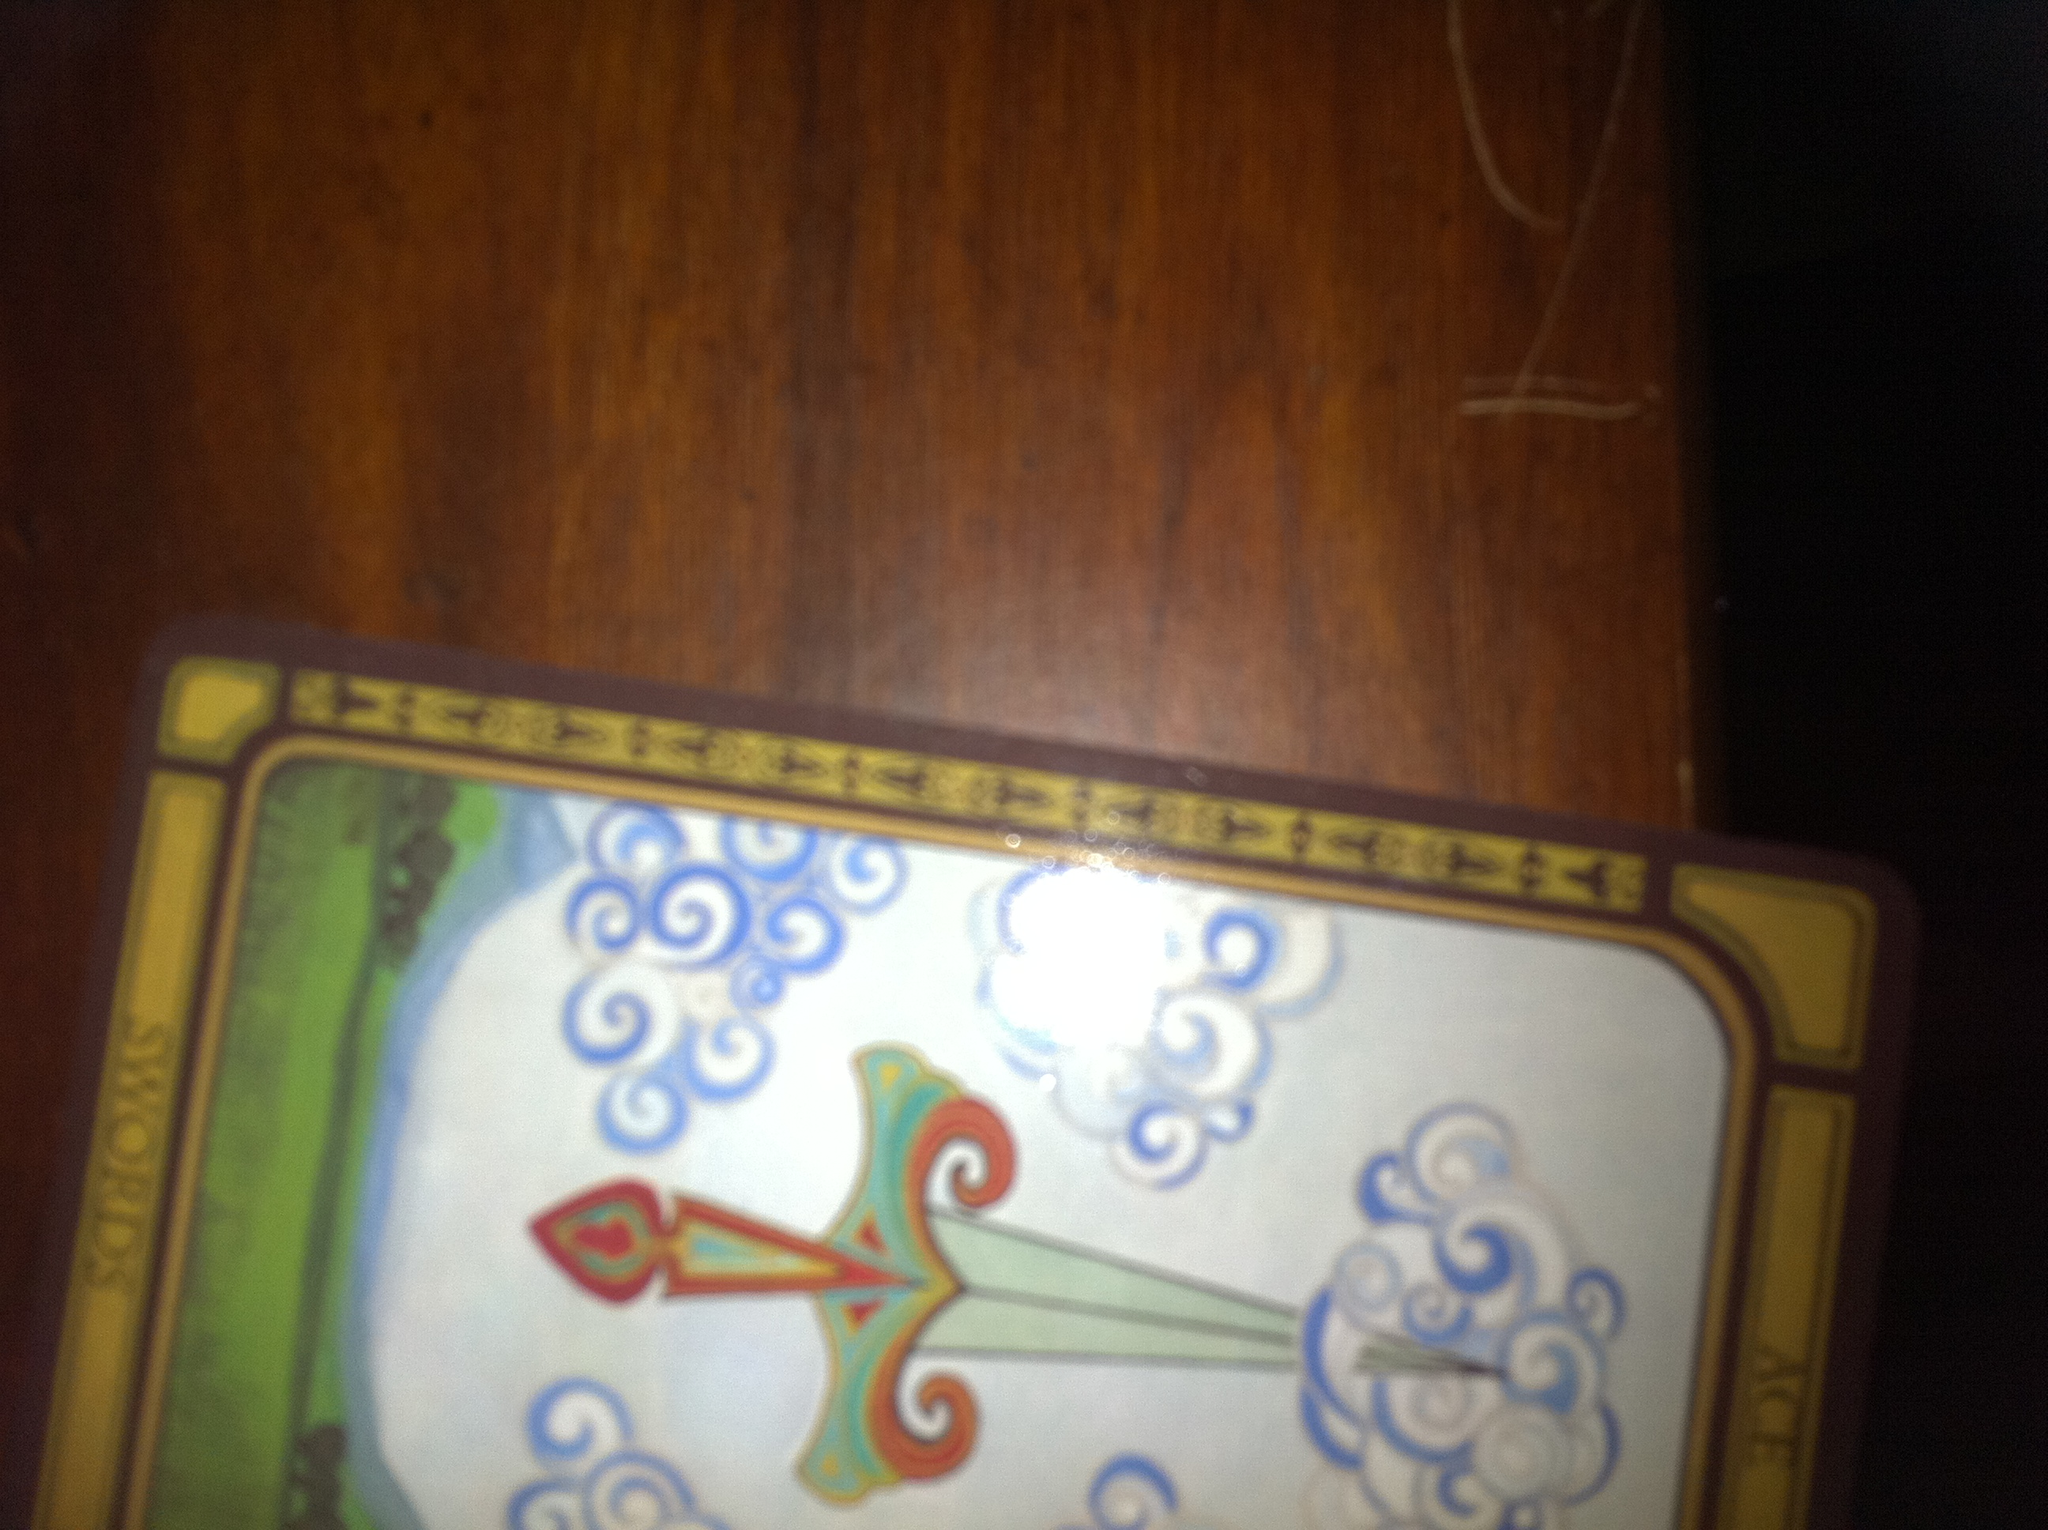If this card were a character in a story, what would its role be? In a story, the Ace of Swords could be a wise, strategic leader who provides guidance with clear vision and intellectual power. This character could be a hero who helps others overcome obstacles by cutting through confusion and bringing clarity to complex situations. 